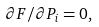<formula> <loc_0><loc_0><loc_500><loc_500>\partial F / \partial P _ { i } = 0 ,</formula> 